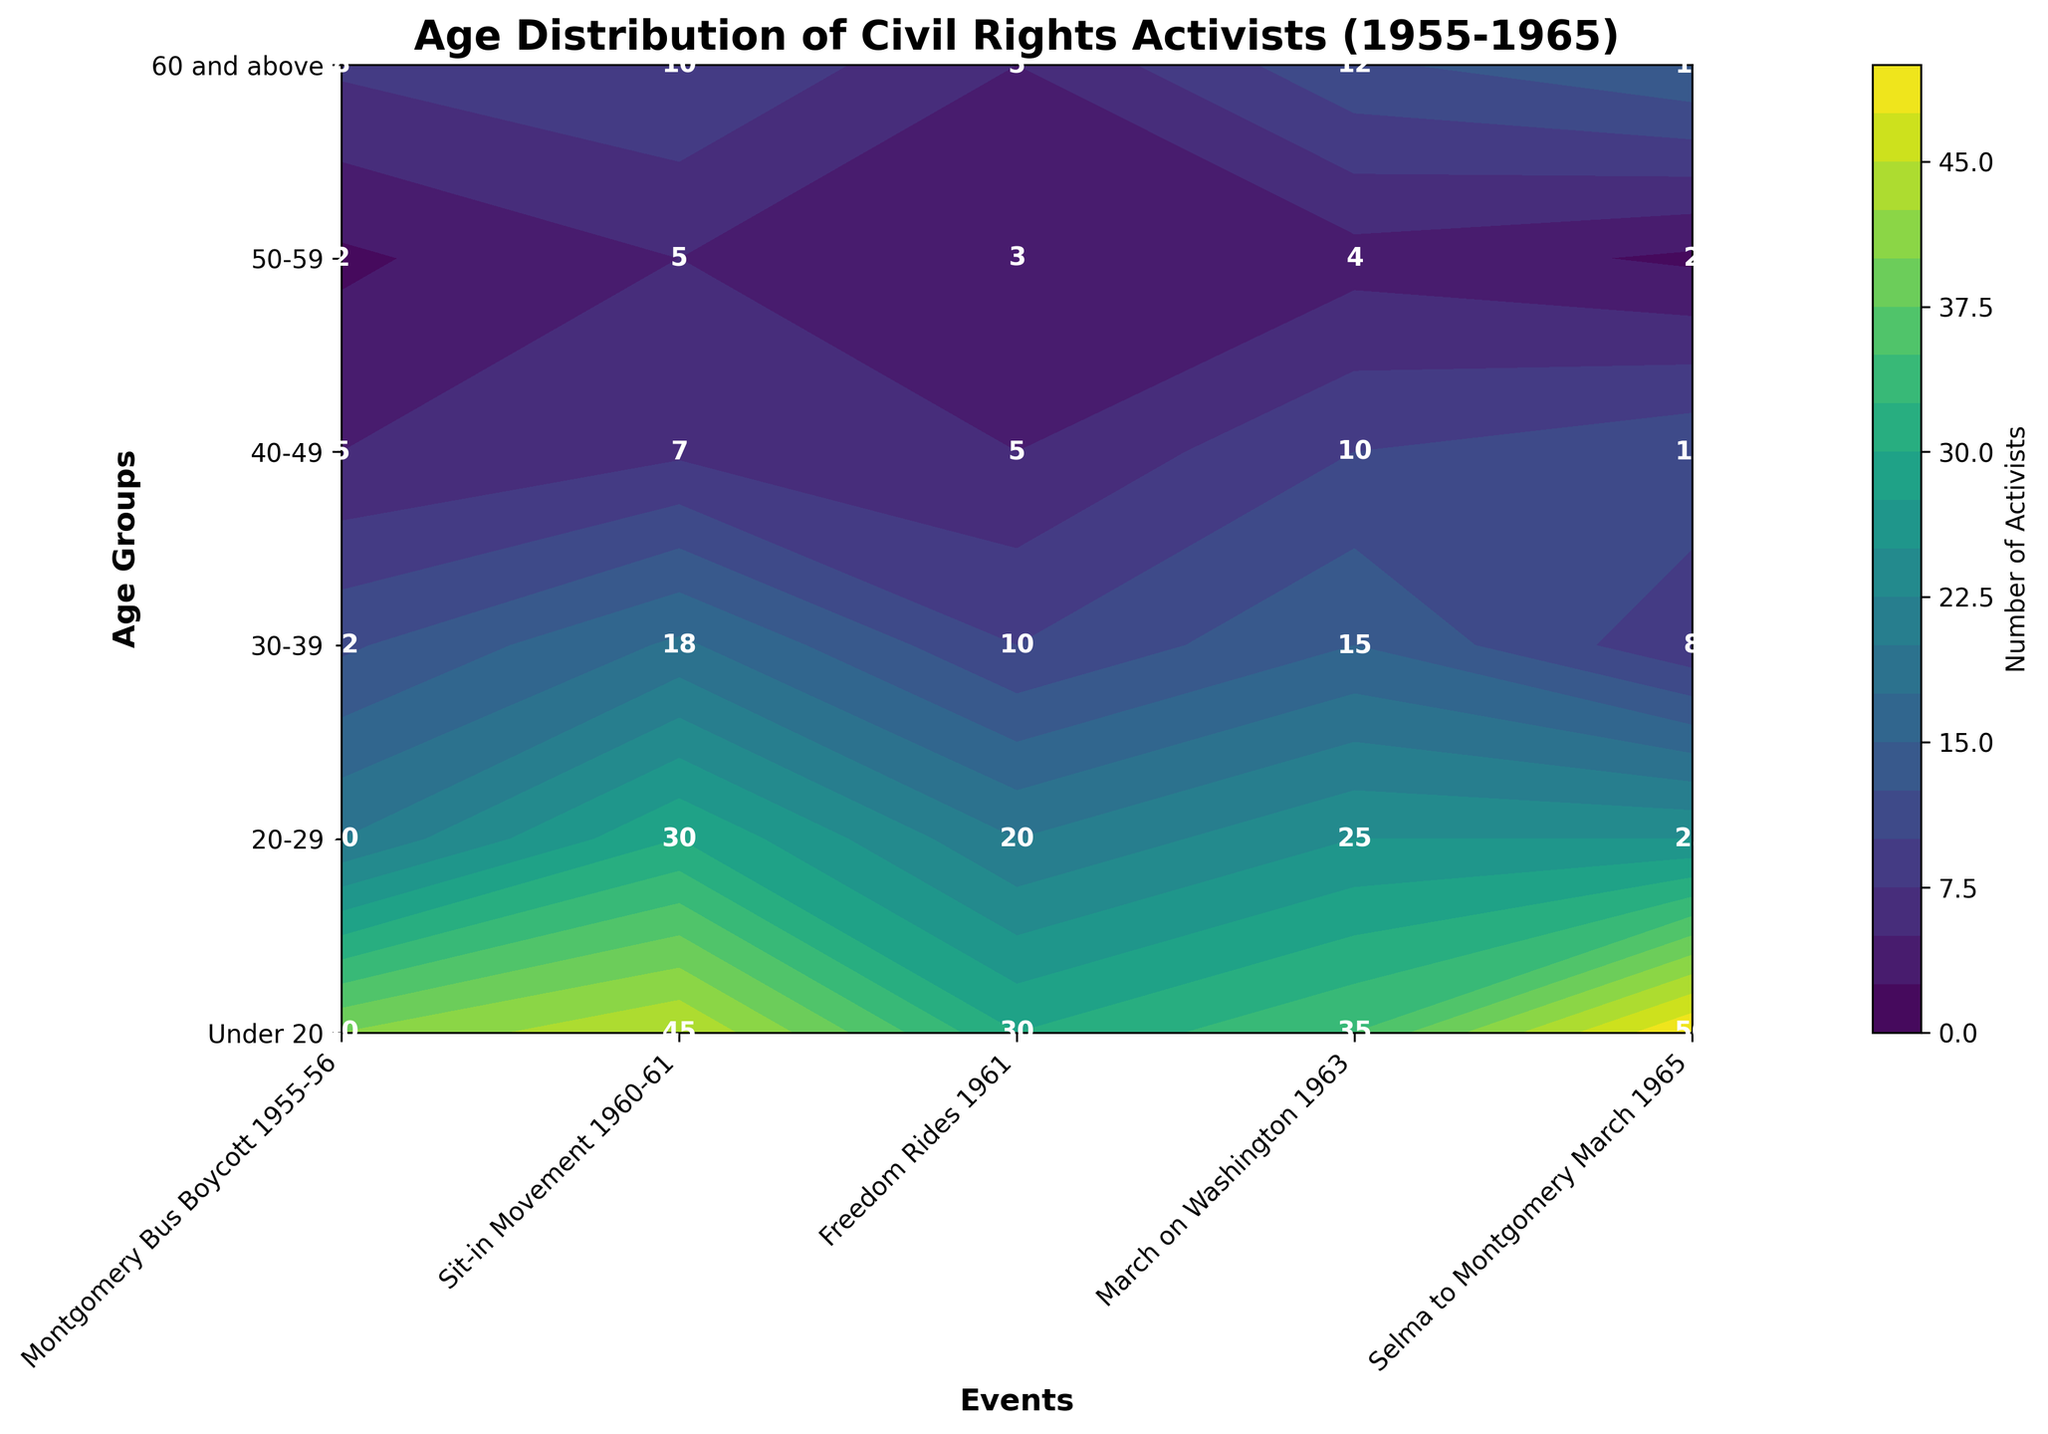What is the title of the figure? The title can be found at the top of the figure. The text reads, "Age Distribution of Civil Rights Activists (1955-1965)."
Answer: Age Distribution of Civil Rights Activists (1955-1965) Which event has the most activists in the 20-29 age group? This can be determined by comparing the numbers for the 20-29 age group across different events. The Sit-in Movement 1960-61 has the highest number of activists in this group with 50.
Answer: Sit-in Movement 1960-61 What is the total number of activists for the Selma to Montgomery March 1965? Add up the numbers in all age groups for the Selma to Montgomery March 1965: 12 (Under 20) + 35 (20-29) + 25 (30-39) + 15 (40-49) + 10 (50-59) + 4 (60 and above).
Answer: 101 Which age group had the fewest activists during the March on Washington 1963? Look at the numbers for each age group participating in the March on Washington 1963 and identify the smallest number. The age group "60 and above" has the fewest activists with 5.
Answer: 60 and above What's the difference in the number of activists between the 30-39 and 50-59 age groups during the Sit-in Movement 1960-61? Subtract the number of activists in the 50-59 age group (12) from the number in the 30-39 age group (25) during the Sit-in Movement 1960-61. 25 - 12 = 13.
Answer: 13 Which event had the highest number of activists in the 60 and above age group? Look at the numbers for the 60 and above age group across all events. The Montgomery Bus Boycott 1955-56 had the highest number of activists in this age group with 3.
Answer: Montgomery Bus Boycott 1955-56 During which event did the under 20 age group have the highest participation? Compare the numbers of participants from the under 20 age group across all events. The Sit-in Movement 1960-61 had the highest number with 15.
Answer: Sit-in Movement 1960-61 What's the average number of activists in the 40-49 age group across all events? Add up the number of activists in the 40-49 age group for each event, then divide by the number of events. (10 + 8 + 12 + 18 + 15) / 5 = 12.6
Answer: 12.6 Which age group showed an increasing trend in participation from the Montgomery Bus Boycott 1955-56 to the March on Washington 1963? Compare the number of participants in each age group across the specific events. The 20-29 age group shows an increasing trend: 30 (Montgomery Bus Boycott 1955-56) to 45 (March on Washington 1963).
Answer: 20-29 Which event has the most even distribution of activists across all age groups? Look for the event where the numbers across all age groups are the most similar. The Selma to Montgomery March 1965 seems to have a relatively even distribution: 12, 35, 25, 15, 10, 4.
Answer: Selma to Montgomery March 1965 